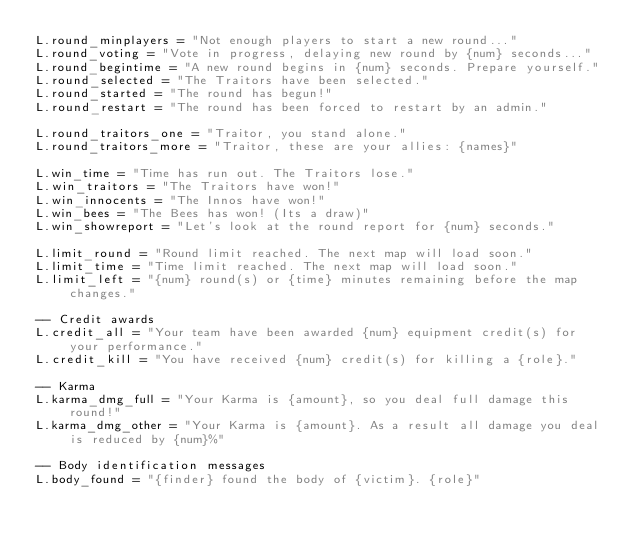Convert code to text. <code><loc_0><loc_0><loc_500><loc_500><_Lua_>L.round_minplayers = "Not enough players to start a new round..."
L.round_voting = "Vote in progress, delaying new round by {num} seconds..."
L.round_begintime = "A new round begins in {num} seconds. Prepare yourself."
L.round_selected = "The Traitors have been selected."
L.round_started = "The round has begun!"
L.round_restart = "The round has been forced to restart by an admin."

L.round_traitors_one = "Traitor, you stand alone."
L.round_traitors_more = "Traitor, these are your allies: {names}"

L.win_time = "Time has run out. The Traitors lose."
L.win_traitors = "The Traitors have won!"
L.win_innocents = "The Innos have won!"
L.win_bees = "The Bees has won! (Its a draw)"
L.win_showreport = "Let's look at the round report for {num} seconds."

L.limit_round = "Round limit reached. The next map will load soon."
L.limit_time = "Time limit reached. The next map will load soon."
L.limit_left = "{num} round(s) or {time} minutes remaining before the map changes."

-- Credit awards
L.credit_all = "Your team have been awarded {num} equipment credit(s) for your performance."
L.credit_kill = "You have received {num} credit(s) for killing a {role}."

-- Karma
L.karma_dmg_full = "Your Karma is {amount}, so you deal full damage this round!"
L.karma_dmg_other = "Your Karma is {amount}. As a result all damage you deal is reduced by {num}%"

-- Body identification messages
L.body_found = "{finder} found the body of {victim}. {role}"</code> 